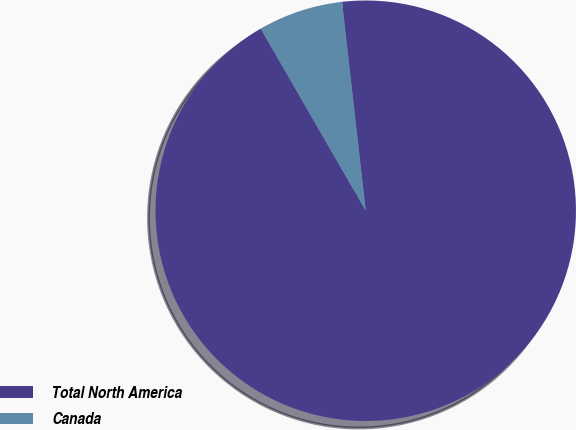Convert chart. <chart><loc_0><loc_0><loc_500><loc_500><pie_chart><fcel>Total North America<fcel>Canada<nl><fcel>93.47%<fcel>6.53%<nl></chart> 